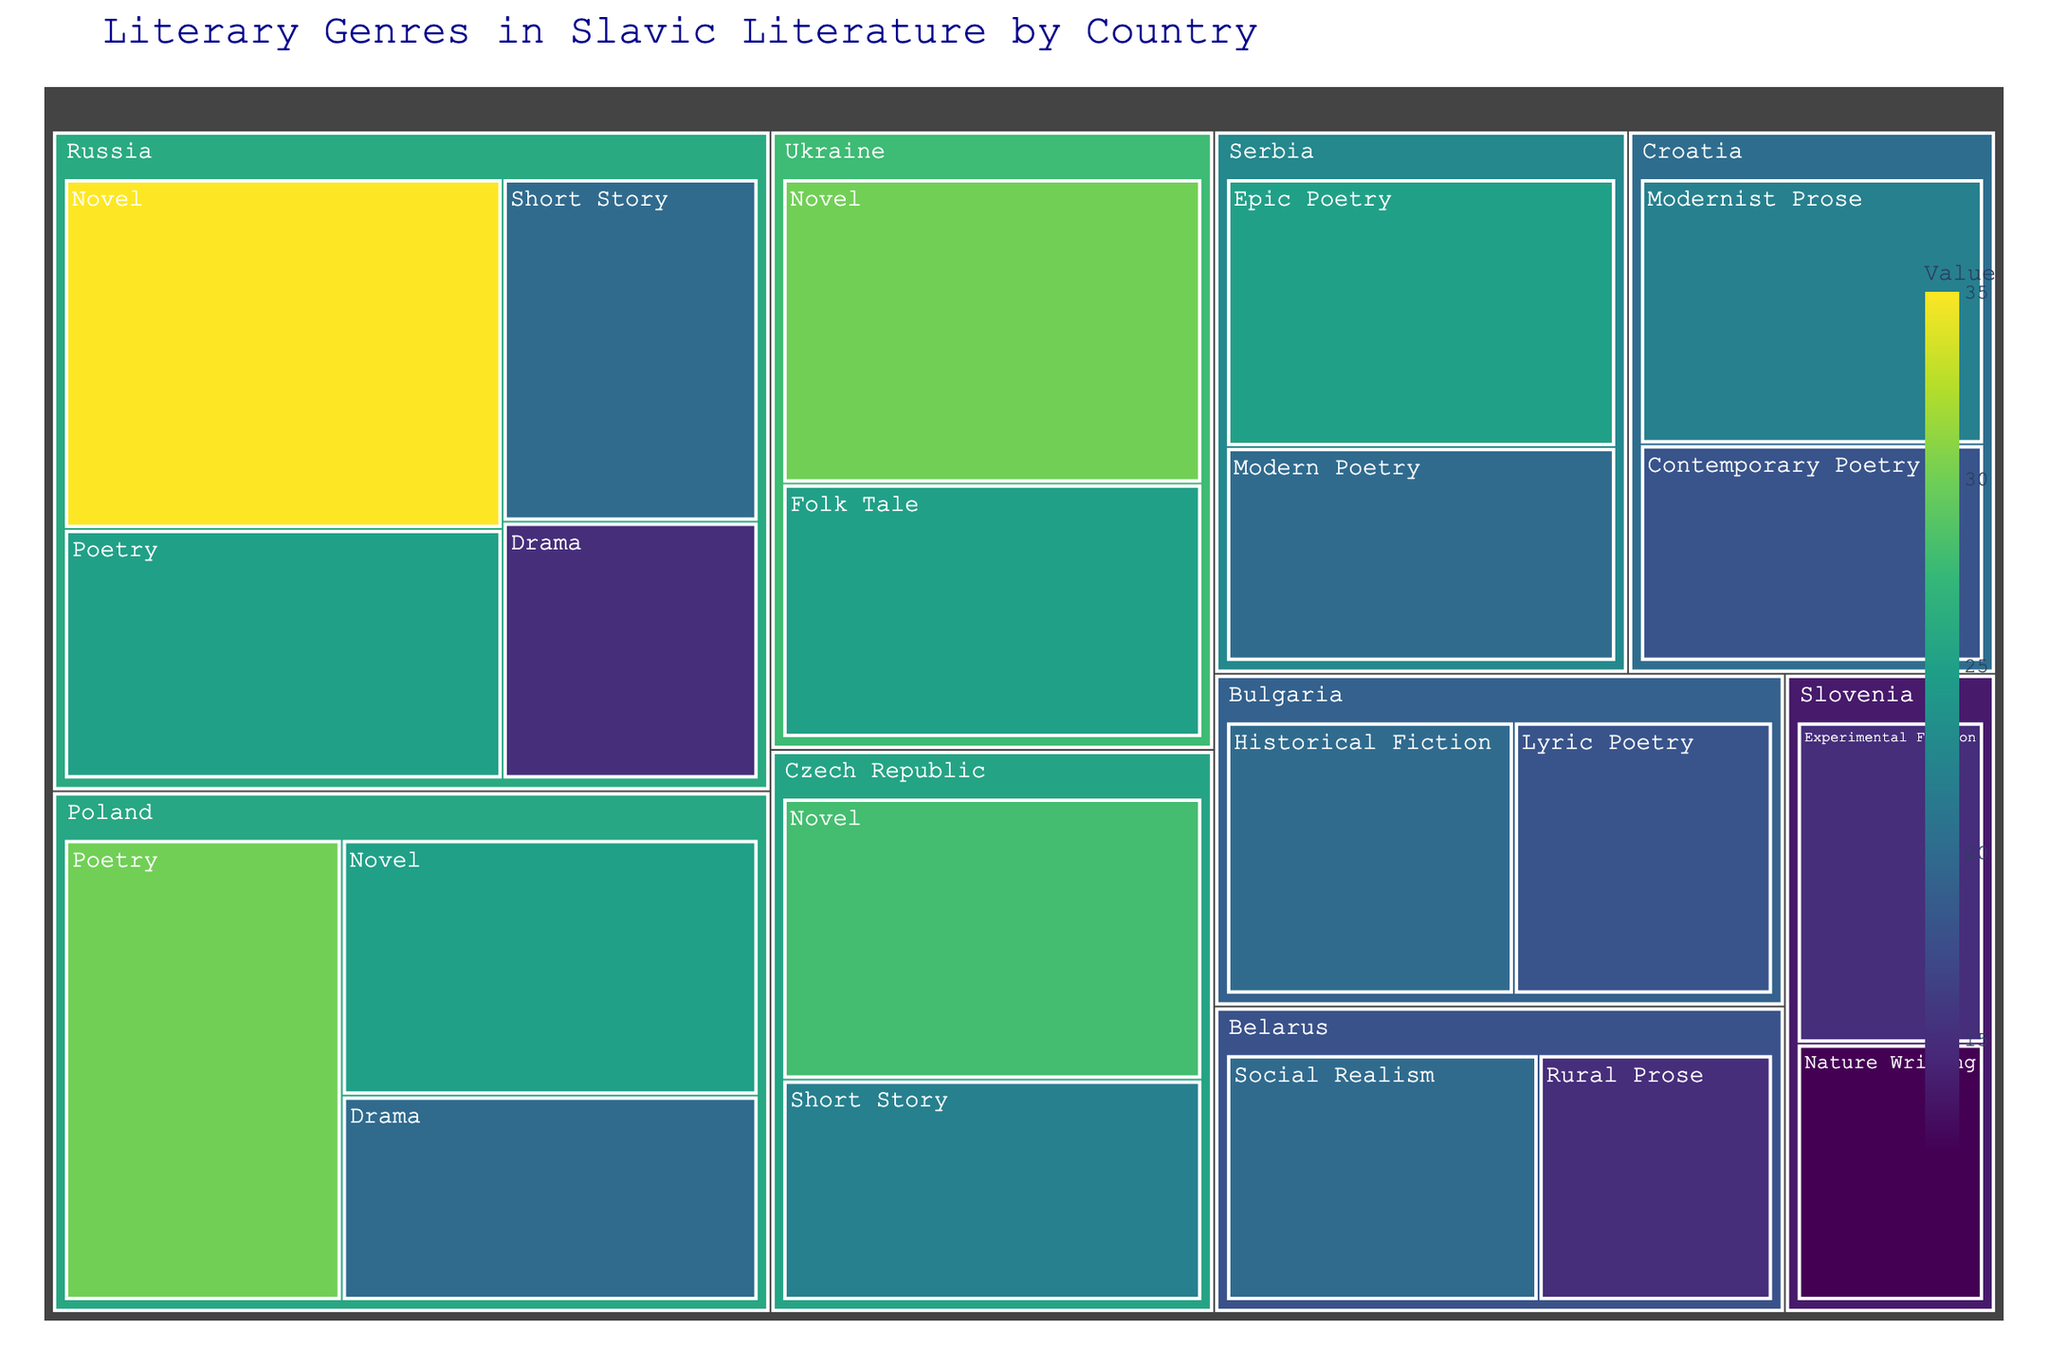What's the title of the figure? The title of the figure is presented at the top center and it reads 'Literary Genres in Slavic Literature by Country'. Simply by looking at this text, we can identify the title.
Answer: Literary Genres in Slavic Literature by Country Which country has the highest value for the genre "Novel"? By scanning through the blocks labelled with "Novel" and noting their corresponding countries, we find that Russia has the highest value for "Novel" with a value of 35.
Answer: Russia What is the total value of genres originating from Poland? First, identify the individual values for genres from Poland: Poetry (30), Novel (25), and Drama (20). Summing these up: 30 + 25 + 20 = 75.
Answer: 75 How does the value of "Drama" in Russia compare to that in Poland? Russia's "Drama" has a value of 15, and Poland's "Drama" has a value of 20. By comparing these two numbers, we see that Poland's value is greater.
Answer: Poland's value is greater Which genre in Slovenia has the smallest value? There are two blocks for Slovenia: "Experimental Fiction" with a value of 15 and "Nature Writing" with a value of 12. The smallest of these values is 12.
Answer: Nature Writing What is the median value of all genres in the Czech Republic? The values for Czech Republic are Novel (28) and Short Story (22). The median of two numbers is the average of those numbers: (28 + 22) / 2 = 25.
Answer: 25 Which country has the most diverse representation of genres? To find this, count the number of unique genres for each country. Russia has four genres, Poland has three, and other countries have one or two. Therefore, Russia has the most diverse representation.
Answer: Russia If you add up the values for all types of poetry from different countries, what’s the total? Sum the values for all poetry genres: Poetry (Russia 25, Poland 30), Epic Poetry (Serbia 25), Modern Poetry (Serbia 20), Lyric Poetry (Bulgaria 18), Contemporary Poetry (Croatia 18). Thus, the total is 25 + 30 + 25 + 20 + 18 + 18 = 136.
Answer: 136 What’s the least represented genre in Bulgaria? Bulgaria has two genres: Historical Fiction (20) and Lyric Poetry (18). The least represented genre has the smaller value, which is Lyric Poetry.
Answer: Lyric Poetry 